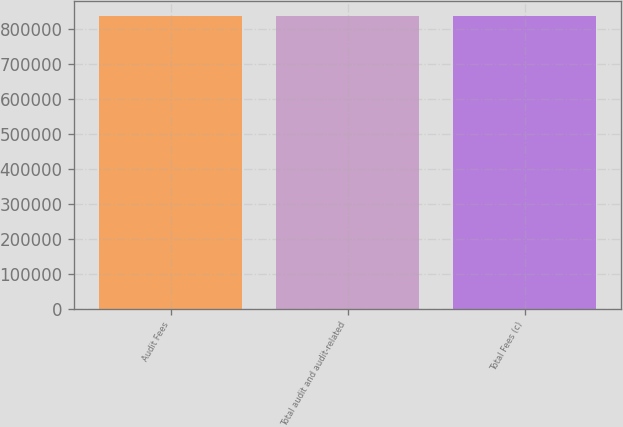Convert chart. <chart><loc_0><loc_0><loc_500><loc_500><bar_chart><fcel>Audit Fees<fcel>Total audit and audit-related<fcel>Total Fees (c)<nl><fcel>838092<fcel>838092<fcel>838092<nl></chart> 